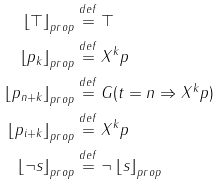<formula> <loc_0><loc_0><loc_500><loc_500>\left \lfloor \top \right \rfloor _ { p r o p } & \stackrel { d e f } { = } \top \\ \left \lfloor p _ { k } \right \rfloor _ { p r o p } & \stackrel { d e f } { = } X ^ { k } p \\ \left \lfloor p _ { n + k } \right \rfloor _ { p r o p } & \stackrel { d e f } { = } G ( t = n \Rightarrow X ^ { k } p ) \\ \left \lfloor p _ { i + k } \right \rfloor _ { p r o p } & \stackrel { d e f } { = } X ^ { k } p \\ \left \lfloor \neg s \right \rfloor _ { p r o p } & \stackrel { d e f } { = } \neg \left \lfloor s \right \rfloor _ { p r o p } \\</formula> 